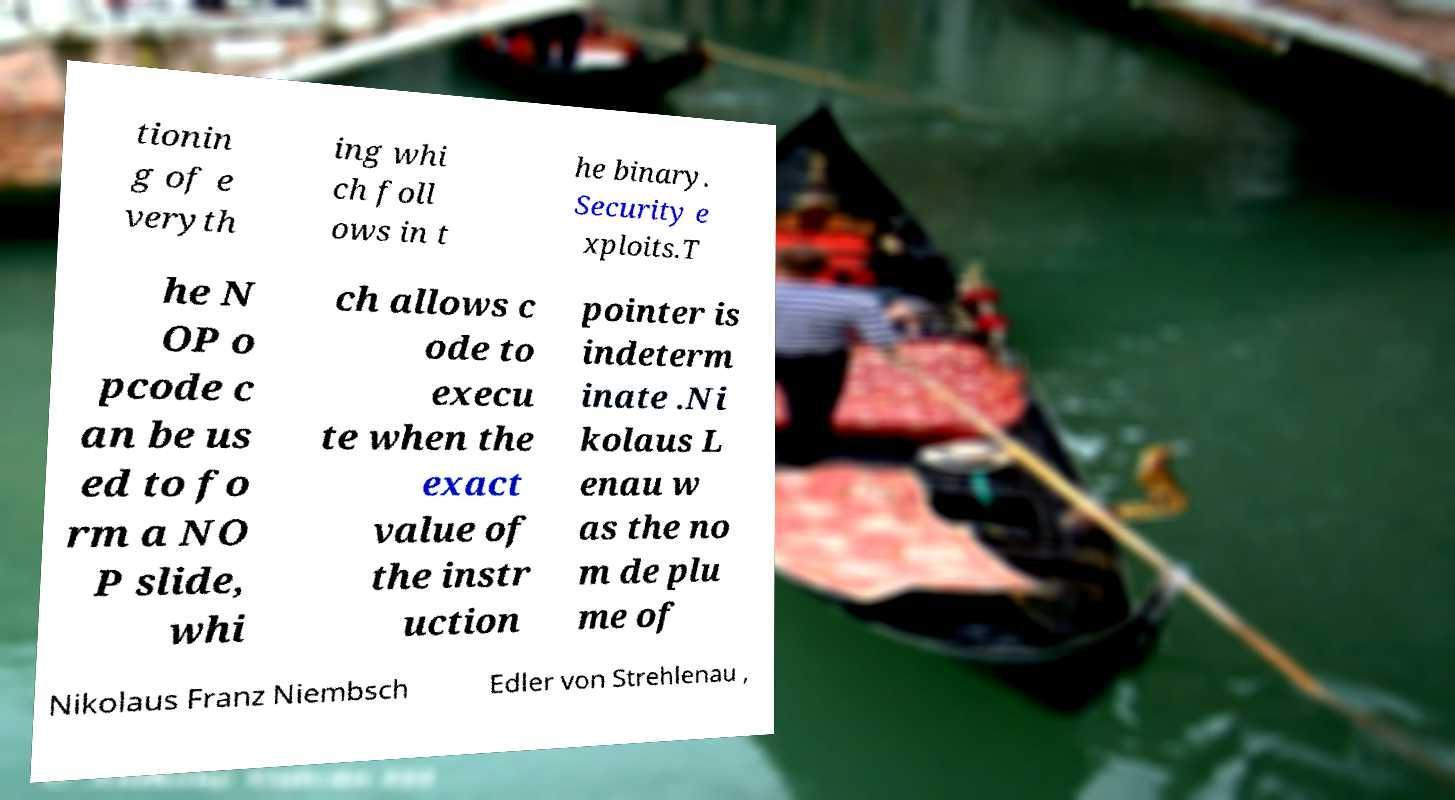Could you assist in decoding the text presented in this image and type it out clearly? tionin g of e veryth ing whi ch foll ows in t he binary. Security e xploits.T he N OP o pcode c an be us ed to fo rm a NO P slide, whi ch allows c ode to execu te when the exact value of the instr uction pointer is indeterm inate .Ni kolaus L enau w as the no m de plu me of Nikolaus Franz Niembsch Edler von Strehlenau , 